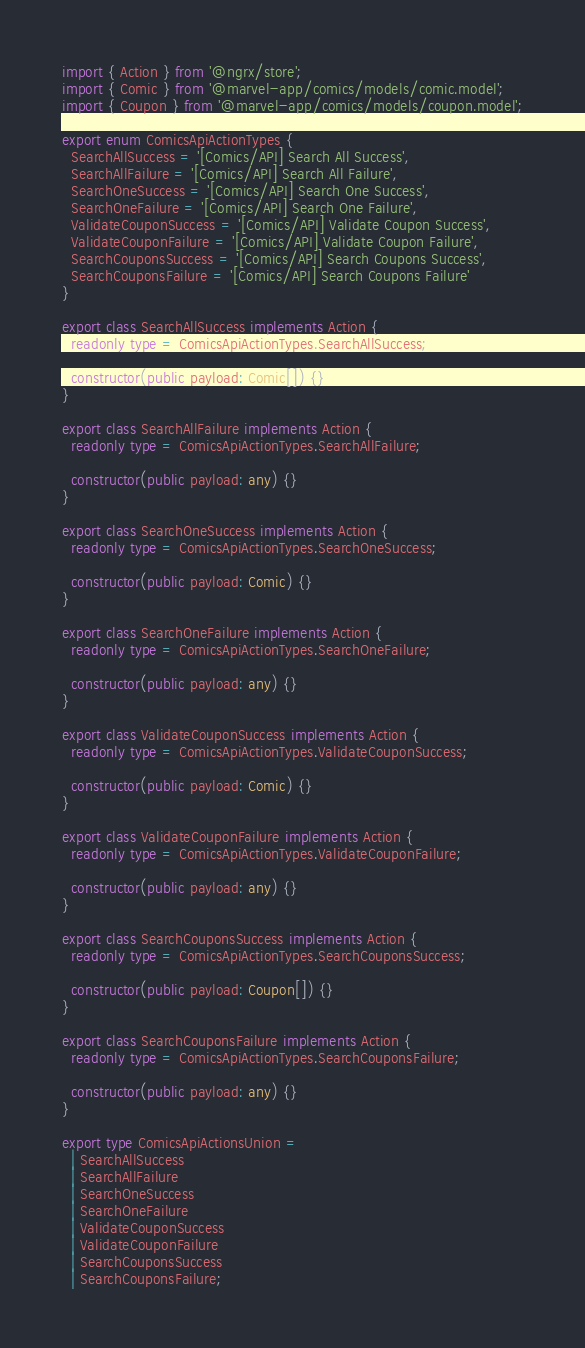<code> <loc_0><loc_0><loc_500><loc_500><_TypeScript_>import { Action } from '@ngrx/store';
import { Comic } from '@marvel-app/comics/models/comic.model';
import { Coupon } from '@marvel-app/comics/models/coupon.model';

export enum ComicsApiActionTypes {
  SearchAllSuccess = '[Comics/API] Search All Success',
  SearchAllFailure = '[Comics/API] Search All Failure',
  SearchOneSuccess = '[Comics/API] Search One Success',
  SearchOneFailure = '[Comics/API] Search One Failure',
  ValidateCouponSuccess = '[Comics/API] Validate Coupon Success',
  ValidateCouponFailure = '[Comics/API] Validate Coupon Failure',
  SearchCouponsSuccess = '[Comics/API] Search Coupons Success',
  SearchCouponsFailure = '[Comics/API] Search Coupons Failure'
}

export class SearchAllSuccess implements Action {
  readonly type = ComicsApiActionTypes.SearchAllSuccess;

  constructor(public payload: Comic[]) {}
}

export class SearchAllFailure implements Action {
  readonly type = ComicsApiActionTypes.SearchAllFailure;

  constructor(public payload: any) {}
}

export class SearchOneSuccess implements Action {
  readonly type = ComicsApiActionTypes.SearchOneSuccess;

  constructor(public payload: Comic) {}
}

export class SearchOneFailure implements Action {
  readonly type = ComicsApiActionTypes.SearchOneFailure;

  constructor(public payload: any) {}
}

export class ValidateCouponSuccess implements Action {
  readonly type = ComicsApiActionTypes.ValidateCouponSuccess;

  constructor(public payload: Comic) {}
}

export class ValidateCouponFailure implements Action {
  readonly type = ComicsApiActionTypes.ValidateCouponFailure;

  constructor(public payload: any) {}
}

export class SearchCouponsSuccess implements Action {
  readonly type = ComicsApiActionTypes.SearchCouponsSuccess;

  constructor(public payload: Coupon[]) {}
}

export class SearchCouponsFailure implements Action {
  readonly type = ComicsApiActionTypes.SearchCouponsFailure;

  constructor(public payload: any) {}
}

export type ComicsApiActionsUnion =
  | SearchAllSuccess
  | SearchAllFailure
  | SearchOneSuccess
  | SearchOneFailure
  | ValidateCouponSuccess
  | ValidateCouponFailure
  | SearchCouponsSuccess
  | SearchCouponsFailure;
</code> 